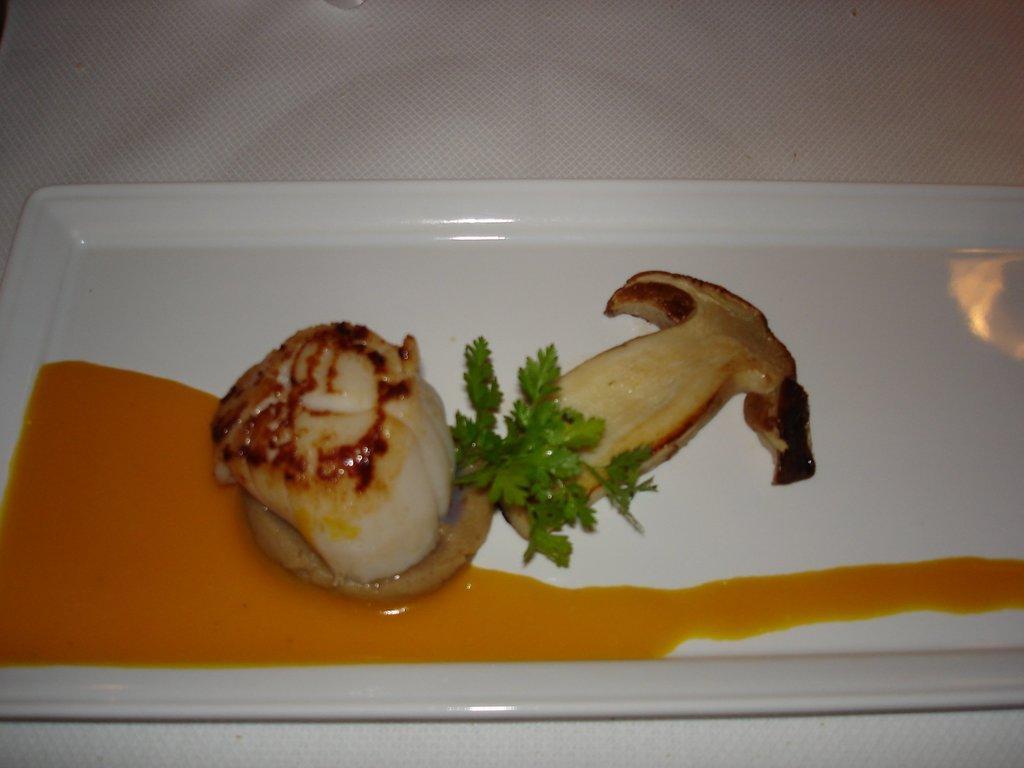In one or two sentences, can you explain what this image depicts? In this image we can see food items in a plate. At the bottom of the image there is tissue. 